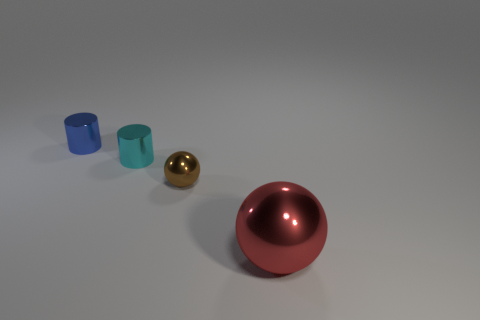What number of big shiny spheres are there?
Give a very brief answer. 1. How many red objects are the same shape as the cyan metal object?
Keep it short and to the point. 0. Does the tiny blue object have the same shape as the cyan shiny object?
Your answer should be very brief. Yes. The red shiny thing has what size?
Provide a short and direct response. Large. What number of spheres have the same size as the blue metal object?
Offer a terse response. 1. Do the object behind the small cyan metal cylinder and the ball that is behind the large metallic thing have the same size?
Your answer should be very brief. Yes. There is a small cyan shiny thing in front of the blue metal cylinder; what is its shape?
Offer a terse response. Cylinder. Do the cyan cylinder and the metal thing that is in front of the tiny brown metal thing have the same size?
Provide a succinct answer. No. What number of balls are behind the sphere in front of the sphere that is left of the red metallic object?
Your answer should be very brief. 1. How many blue metal things are on the right side of the small blue shiny thing?
Keep it short and to the point. 0. 